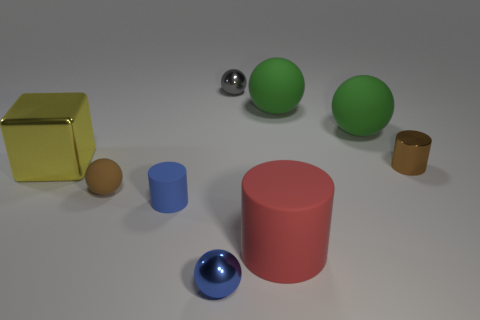Subtract all small matte balls. How many balls are left? 4 Subtract all blue cylinders. How many cylinders are left? 2 Add 1 small purple matte cylinders. How many objects exist? 10 Subtract 2 spheres. How many spheres are left? 3 Subtract all cubes. How many objects are left? 8 Subtract all purple balls. Subtract all purple cubes. How many balls are left? 5 Subtract all purple cubes. How many yellow balls are left? 0 Subtract all rubber things. Subtract all brown spheres. How many objects are left? 3 Add 1 large rubber cylinders. How many large rubber cylinders are left? 2 Add 4 small blue rubber cylinders. How many small blue rubber cylinders exist? 5 